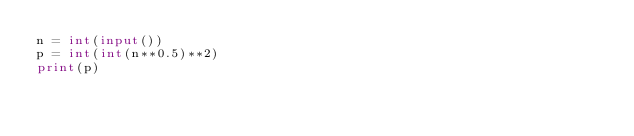<code> <loc_0><loc_0><loc_500><loc_500><_Python_>n = int(input())
p = int(int(n**0.5)**2)
print(p)</code> 